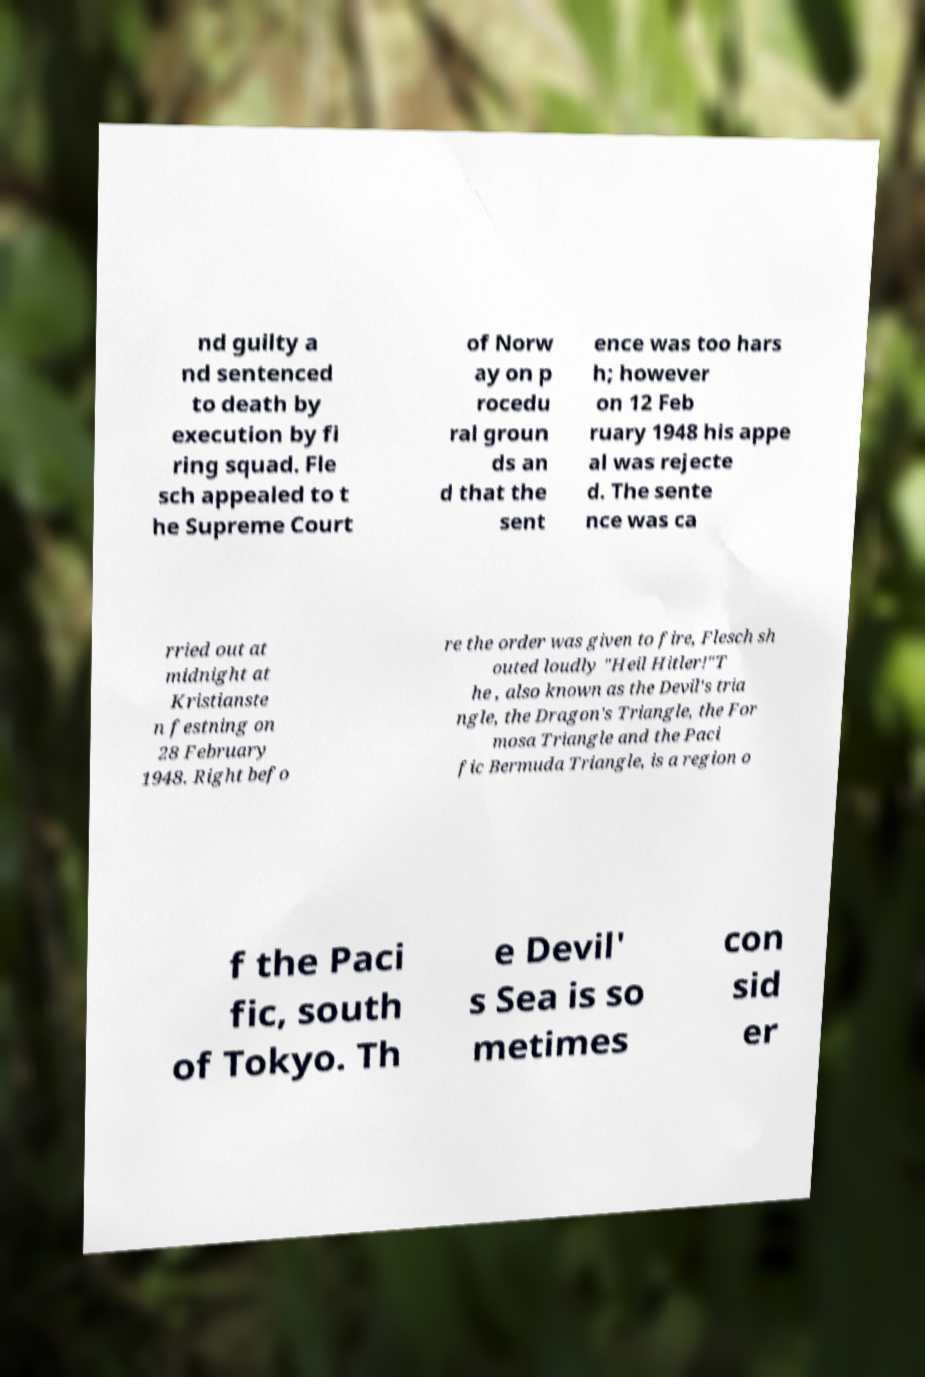Can you accurately transcribe the text from the provided image for me? nd guilty a nd sentenced to death by execution by fi ring squad. Fle sch appealed to t he Supreme Court of Norw ay on p rocedu ral groun ds an d that the sent ence was too hars h; however on 12 Feb ruary 1948 his appe al was rejecte d. The sente nce was ca rried out at midnight at Kristianste n festning on 28 February 1948. Right befo re the order was given to fire, Flesch sh outed loudly "Heil Hitler!"T he , also known as the Devil's tria ngle, the Dragon's Triangle, the For mosa Triangle and the Paci fic Bermuda Triangle, is a region o f the Paci fic, south of Tokyo. Th e Devil' s Sea is so metimes con sid er 